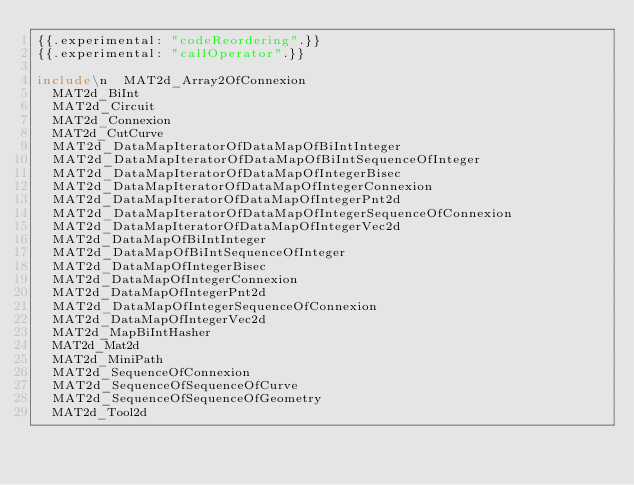<code> <loc_0><loc_0><loc_500><loc_500><_Nim_>{{.experimental: "codeReordering".}}
{{.experimental: "callOperator".}}

include\n  MAT2d_Array2OfConnexion
  MAT2d_BiInt
  MAT2d_Circuit
  MAT2d_Connexion
  MAT2d_CutCurve
  MAT2d_DataMapIteratorOfDataMapOfBiIntInteger
  MAT2d_DataMapIteratorOfDataMapOfBiIntSequenceOfInteger
  MAT2d_DataMapIteratorOfDataMapOfIntegerBisec
  MAT2d_DataMapIteratorOfDataMapOfIntegerConnexion
  MAT2d_DataMapIteratorOfDataMapOfIntegerPnt2d
  MAT2d_DataMapIteratorOfDataMapOfIntegerSequenceOfConnexion
  MAT2d_DataMapIteratorOfDataMapOfIntegerVec2d
  MAT2d_DataMapOfBiIntInteger
  MAT2d_DataMapOfBiIntSequenceOfInteger
  MAT2d_DataMapOfIntegerBisec
  MAT2d_DataMapOfIntegerConnexion
  MAT2d_DataMapOfIntegerPnt2d
  MAT2d_DataMapOfIntegerSequenceOfConnexion
  MAT2d_DataMapOfIntegerVec2d
  MAT2d_MapBiIntHasher
  MAT2d_Mat2d
  MAT2d_MiniPath
  MAT2d_SequenceOfConnexion
  MAT2d_SequenceOfSequenceOfCurve
  MAT2d_SequenceOfSequenceOfGeometry
  MAT2d_Tool2d




















































</code> 